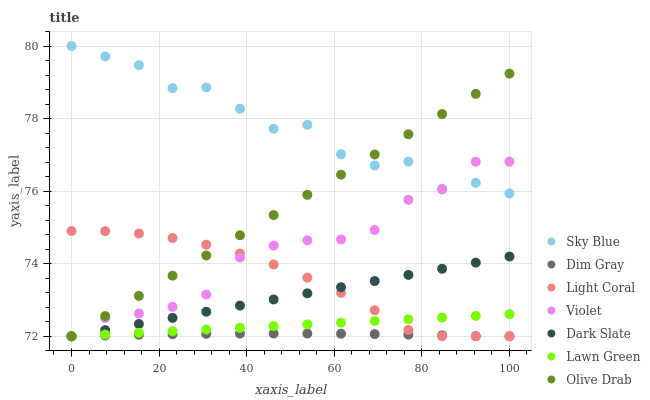Does Dim Gray have the minimum area under the curve?
Answer yes or no. Yes. Does Sky Blue have the maximum area under the curve?
Answer yes or no. Yes. Does Light Coral have the minimum area under the curve?
Answer yes or no. No. Does Light Coral have the maximum area under the curve?
Answer yes or no. No. Is Lawn Green the smoothest?
Answer yes or no. Yes. Is Sky Blue the roughest?
Answer yes or no. Yes. Is Dim Gray the smoothest?
Answer yes or no. No. Is Dim Gray the roughest?
Answer yes or no. No. Does Lawn Green have the lowest value?
Answer yes or no. Yes. Does Sky Blue have the lowest value?
Answer yes or no. No. Does Sky Blue have the highest value?
Answer yes or no. Yes. Does Light Coral have the highest value?
Answer yes or no. No. Is Dark Slate less than Sky Blue?
Answer yes or no. Yes. Is Sky Blue greater than Lawn Green?
Answer yes or no. Yes. Does Sky Blue intersect Olive Drab?
Answer yes or no. Yes. Is Sky Blue less than Olive Drab?
Answer yes or no. No. Is Sky Blue greater than Olive Drab?
Answer yes or no. No. Does Dark Slate intersect Sky Blue?
Answer yes or no. No. 